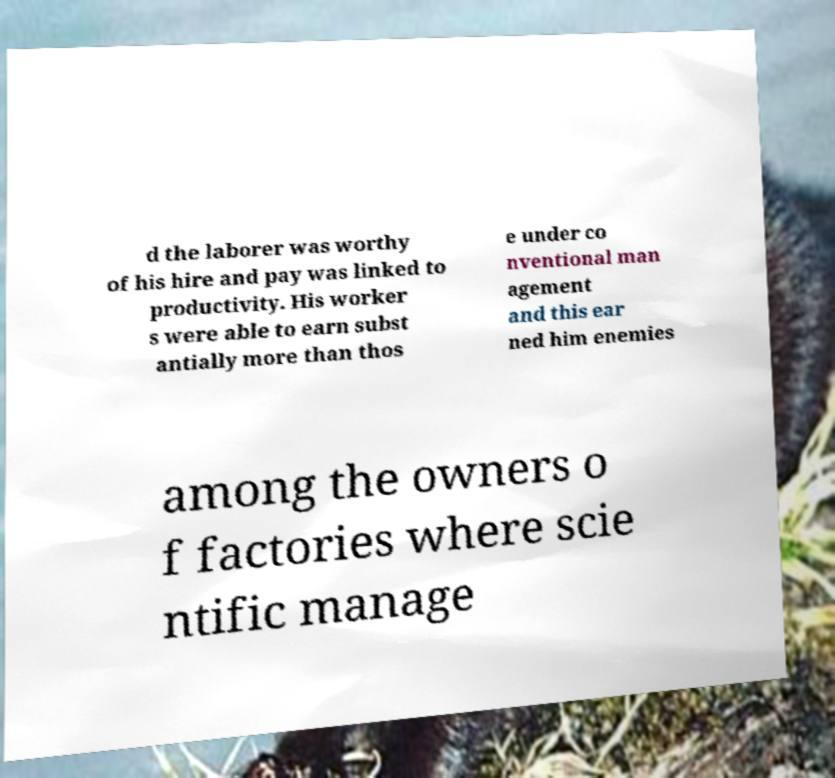There's text embedded in this image that I need extracted. Can you transcribe it verbatim? d the laborer was worthy of his hire and pay was linked to productivity. His worker s were able to earn subst antially more than thos e under co nventional man agement and this ear ned him enemies among the owners o f factories where scie ntific manage 